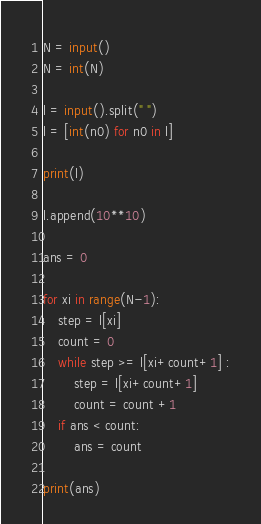Convert code to text. <code><loc_0><loc_0><loc_500><loc_500><_Python_>N = input()
N = int(N)

l = input().split(" ")
l = [int(n0) for n0 in l]

print(l)

l.append(10**10)

ans = 0

for xi in range(N-1):
    step = l[xi]
    count = 0
    while step >= l[xi+count+1] :
        step = l[xi+count+1]
        count = count +1
    if ans < count:
        ans = count

print(ans)
</code> 